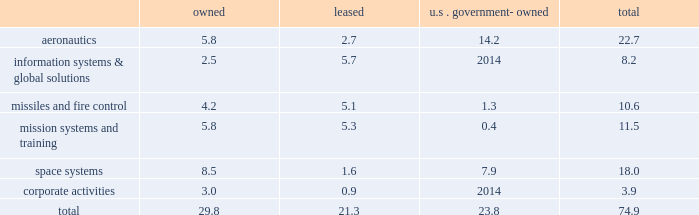Reporting unit 2019s related goodwill assets .
In 2013 , we recorded a non-cash goodwill impairment charge of $ 195 million , net of state tax benefits .
See 201ccritical accounting policies - goodwill 201d in management 2019s discussion and analysis of financial condition and results of operations and 201cnote 1 2013 significant accounting policies 201d for more information on this impairment charge .
Changes in u.s .
Or foreign tax laws , including possibly with retroactive effect , and audits by tax authorities could result in unanticipated increases in our tax expense and affect profitability and cash flows .
For example , proposals to lower the u.s .
Corporate income tax rate would require us to reduce our net deferred tax assets upon enactment of the related tax legislation , with a corresponding material , one-time increase to income tax expense , but our income tax expense and payments would be materially reduced in subsequent years .
Actual financial results could differ from our judgments and estimates .
Refer to 201ccritical accounting policies 201d in management 2019s discussion and analysis of financial condition and results of operations , and 201cnote 1 2013 significant accounting policies 201d of our consolidated financial statements for a complete discussion of our significant accounting policies and use of estimates .
Item 1b .
Unresolved staff comments .
Item 2 .
Properties .
At december 31 , 2013 , we owned or leased building space ( including offices , manufacturing plants , warehouses , service centers , laboratories , and other facilities ) at 518 locations primarily in the u.s .
Additionally , we manage or occupy various u.s .
Government-owned facilities under lease and other arrangements .
At december 31 , 2013 , we had significant operations in the following locations : 2022 aeronautics 2013 palmdale , california ; marietta , georgia ; greenville , south carolina ; fort worth and san antonio , texas ; and montreal , canada .
2022 information systems & global solutions 2013 goodyear , arizona ; sunnyvale , california ; colorado springs and denver , colorado ; gaithersburg and rockville , maryland ; valley forge , pennsylvania ; and houston , texas .
2022 missiles and fire control 2013 camden , arkansas ; orlando , florida ; lexington , kentucky ; and grand prairie , texas .
2022 mission systems and training 2013 orlando , florida ; baltimore , maryland ; moorestown/mt .
Laurel , new jersey ; owego and syracuse , new york ; akron , ohio ; and manassas , virginia .
2022 space systems 2013 huntsville , alabama ; sunnyvale , california ; denver , colorado ; albuquerque , new mexico ; and newtown , pennsylvania .
2022 corporate activities 2013 lakeland , florida and bethesda , maryland .
In november 2013 , we committed to a plan to vacate our leased facilities in goodyear , arizona and akron , ohio , and close our owned facility in newtown , pennsylvania and certain owned buildings at our sunnyvale , california facility .
We expect these closures , which include approximately 2.5 million square feet of facility space , will be substantially complete by the middle of 2015 .
For information regarding these matters , see 201cnote 2 2013 restructuring charges 201d of our consolidated financial statements .
The following is a summary of our square feet of floor space by business segment at december 31 , 2013 , inclusive of the facilities that we plan to vacate as mentioned above ( in millions ) : owned leased u.s .
Government- owned total .
We believe our facilities are in good condition and adequate for their current use .
We may improve , replace , or reduce facilities as considered appropriate to meet the needs of our operations. .
What percentage of total square feet of floor space by business segment at december 31 , 2013 is in aeronautics? 
Computations: (22.7 / 74.9)
Answer: 0.30307. 